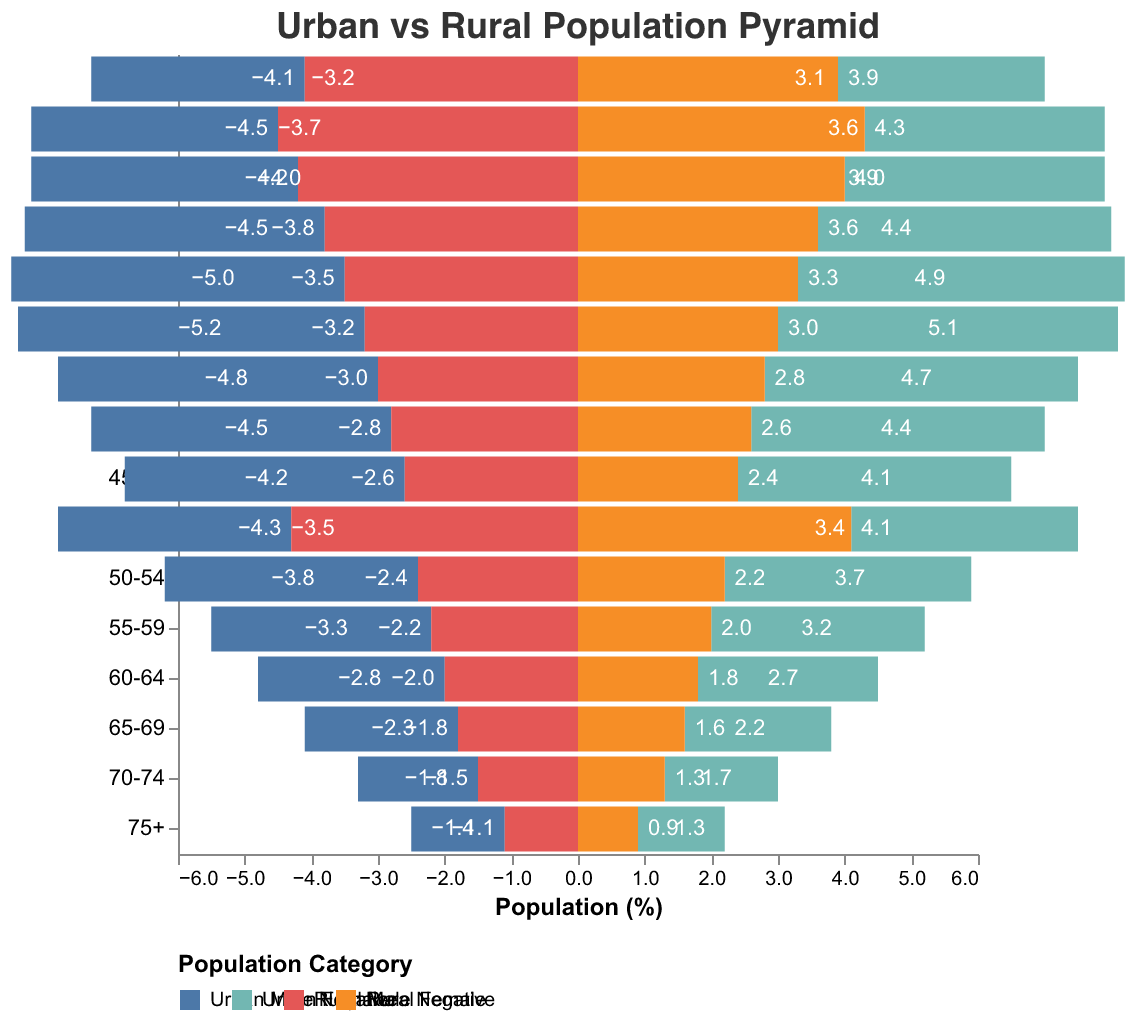What is the title of the figure? The title of the figure can be found at the top and it is often displayed prominently. It summarizes the main topic of the figure.
Answer: Urban vs Rural Population Pyramid Which age group has the highest percentage of urban females? To determine this, look at the values corresponding to "Urban Female" across all age groups and identify the maximum value.
Answer: 30-34 How does the percentage of rural males in the age group 0-4 compare to urban males in the same age group? Compare the values given for "Urban Male" and "Rural Male" within the age group 0-4.
Answer: Rural males have a higher percentage (4.1%) than urban males (3.2%) In which age group is the difference between urban males and rural males the greatest? Calculate the difference between "Urban Male" and "Rural Male" for all age groups and identify the maximum difference.
Answer: 30-34 What is the combined percentage of urban and rural females in the age group 20-24? Add the percentages of "Urban Female" and "Rural Female" for the age group 20-24.
Answer: 4.4 + 3.6 = 8.0% Which gender has a higher population percentage in the urban area for the age group 25-29? Compare the percentages of "Urban Male" and "Urban Female" for the age group 25-29.
Answer: Urban Male Are there any age groups where the percentage of rural females is less than 1%? Scan through the percentages for "Rural Female" across all age groups to check if any are less than 1%.
Answer: Yes, in the age group 75+ For the age group 55-59, is the percentage of urban males higher than the percentage of rural males? Compare the values for "Urban Male" and "Rural Male" within the age group 55-59.
Answer: Yes, 3.3% (Urban Male) is higher than 2.2% (Rural Male) On average, which region (urban or rural) has a higher percentage of the population in the age group 10-19? Calculate the averages of "Urban Male," "Urban Female," "Rural Male," and "Rural Female" for the combined age groups 10-14 and 15-19, then compare the urban and rural average percentages.
Answer: Urban average: (3.7 + 3.6 + 4.0 + 3.9) / 2 = 7.6, Rural average: (4.5 + 4.3 + 4.2 + 4.0) / 2 = 8.35, so Rural 